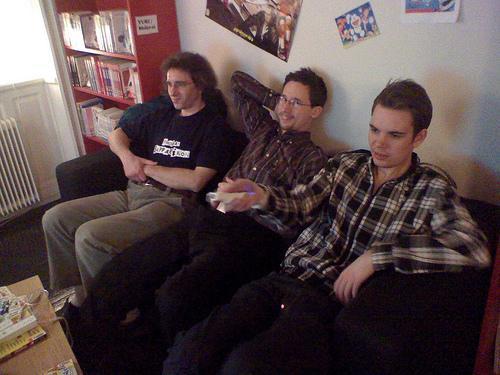How many people are shown?
Give a very brief answer. 3. How many pictures are on the wall?
Give a very brief answer. 3. 